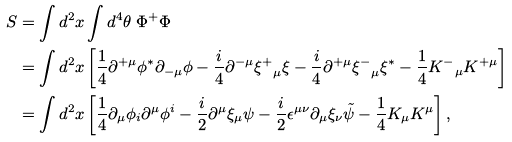Convert formula to latex. <formula><loc_0><loc_0><loc_500><loc_500>S & = \int d ^ { 2 } x \int d ^ { 4 } \theta \ \Phi ^ { + } \Phi \\ & = \int d ^ { 2 } x \left [ \frac { 1 } { 4 } \partial ^ { + \mu } \phi ^ { * } \partial _ { - \mu } \phi - \frac { i } { 4 } \partial ^ { - \mu } { \xi ^ { + } } _ { \mu } \xi - \frac { i } { 4 } \partial ^ { + \mu } { \xi ^ { - } } _ { \mu } \xi ^ { * } - \frac { 1 } { 4 } { K ^ { - } } _ { \mu } K ^ { + \mu } \right ] \\ & = \int d ^ { 2 } x \left [ \frac { 1 } { 4 } \partial _ { \mu } \phi _ { i } \partial ^ { \mu } \phi ^ { i } - \frac { i } { 2 } \partial ^ { \mu } \xi _ { \mu } \psi - \frac { i } { 2 } \epsilon ^ { \mu \nu } \partial _ { \mu } \xi _ { \nu } \tilde { \psi } - \frac { 1 } { 4 } K _ { \mu } K ^ { \mu } \right ] ,</formula> 